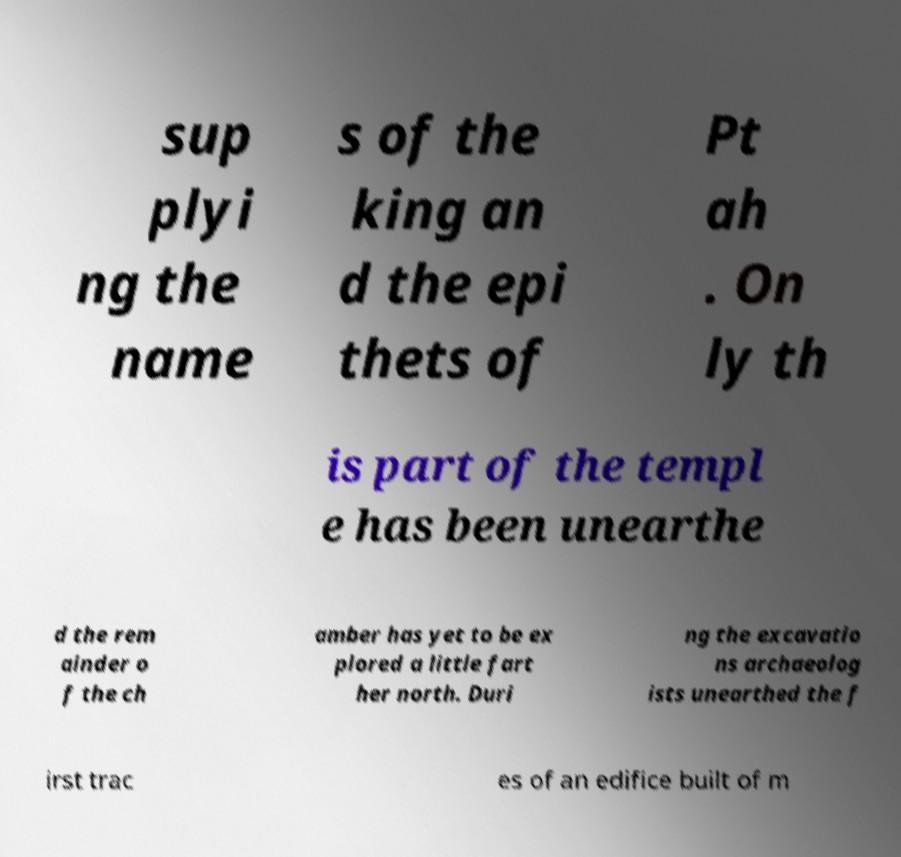What messages or text are displayed in this image? I need them in a readable, typed format. sup plyi ng the name s of the king an d the epi thets of Pt ah . On ly th is part of the templ e has been unearthe d the rem ainder o f the ch amber has yet to be ex plored a little fart her north. Duri ng the excavatio ns archaeolog ists unearthed the f irst trac es of an edifice built of m 